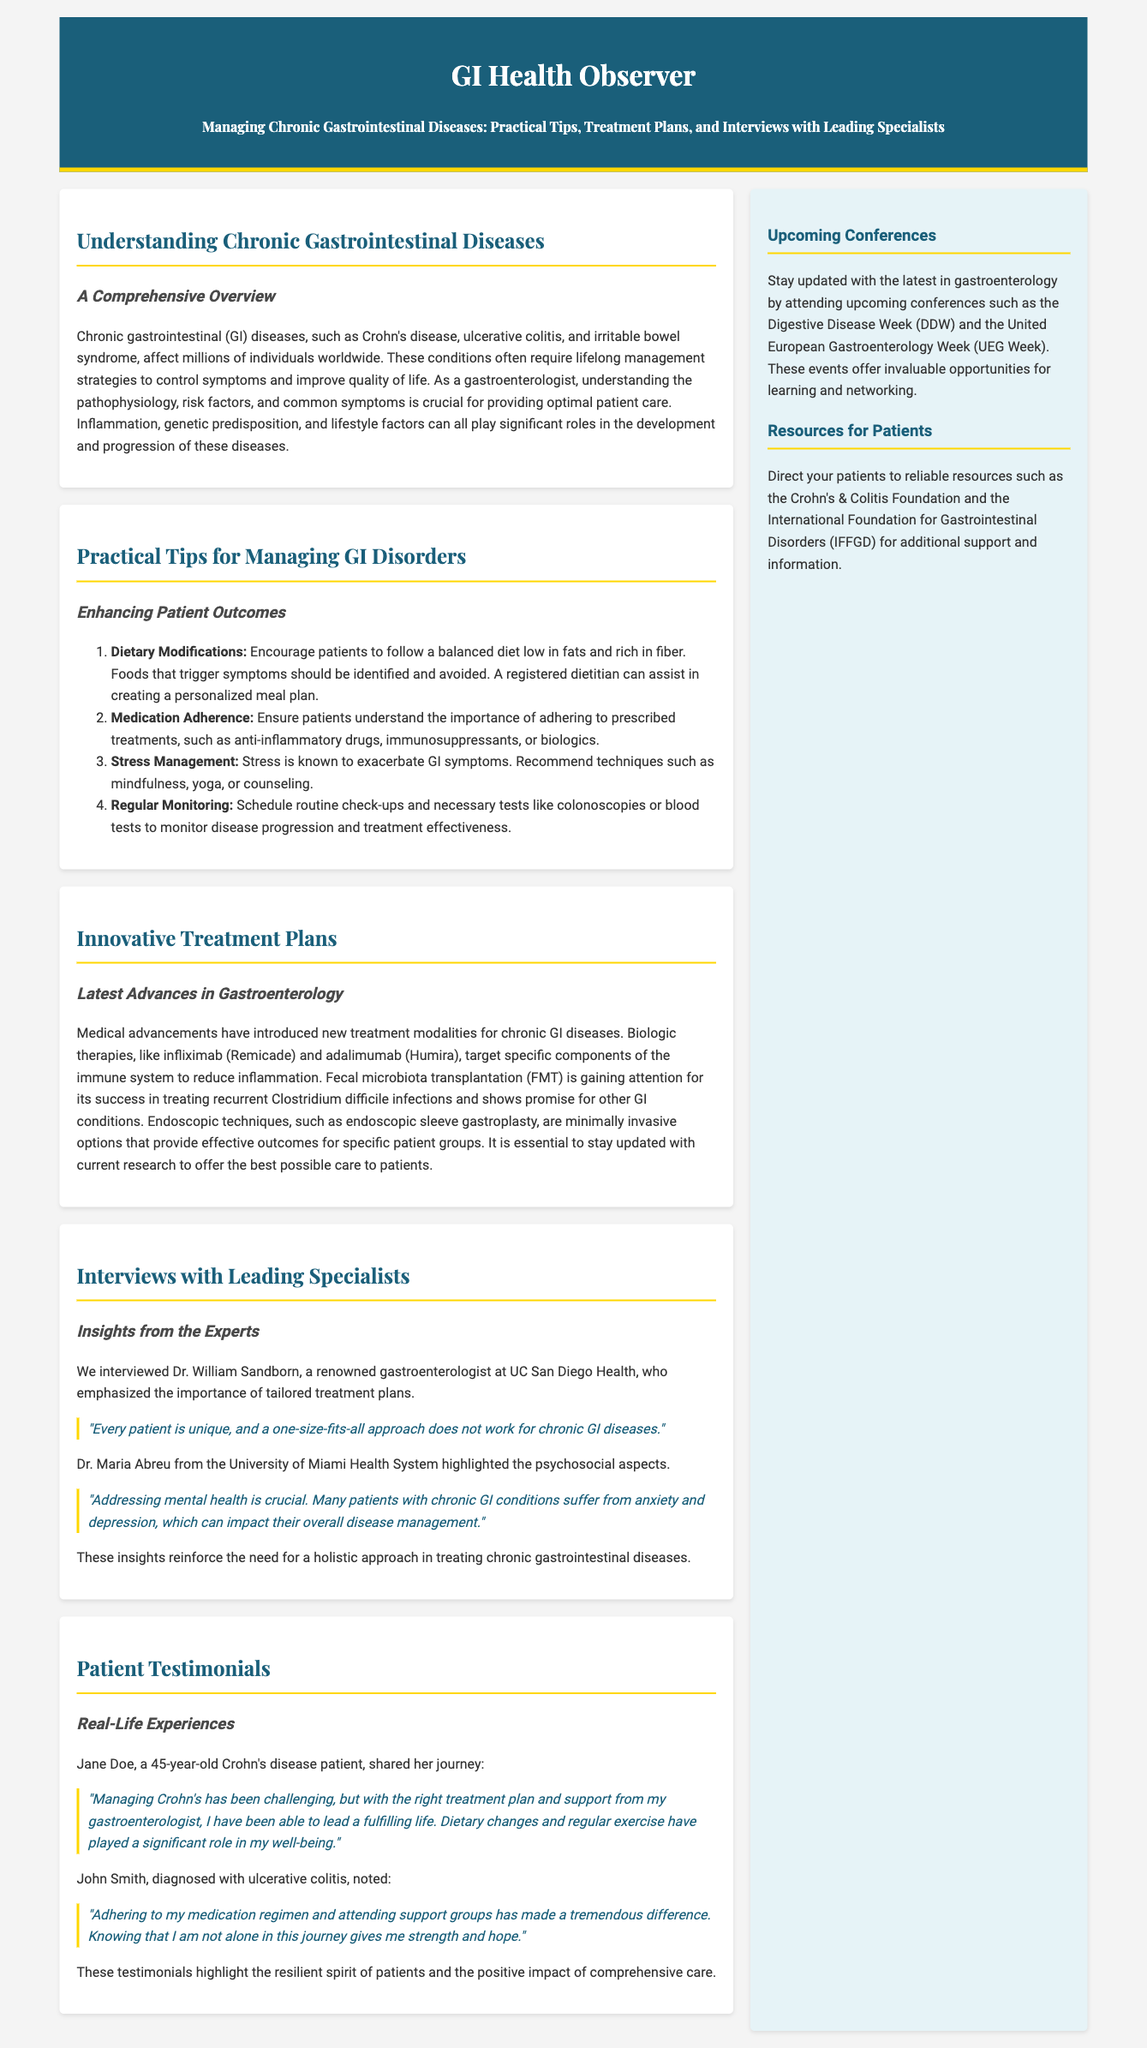What are some examples of chronic gastrointestinal diseases? The document lists several chronic gastrointestinal diseases including Crohn's disease and ulcerative colitis.
Answer: Crohn's disease, ulcerative colitis What is a recommended dietary modification for managing GI disorders? The document suggests that a balanced diet low in fats and rich in fiber is important for managing GI disorders.
Answer: Low in fats and rich in fiber Which therapy targets specific components of the immune system? Biologic therapies such as infliximab and adalimumab are highlighted as treatments that target the immune system.
Answer: Biologic therapies Who emphasized tailored treatment plans in the document? Dr. William Sandborn, a gastroenterologist at UC San Diego Health, is quoted regarding tailored treatment plans.
Answer: Dr. William Sandborn What is a common psychosocial impact mentioned for patients with chronic GI conditions? Anxiety and depression are noted as common psychosocial impacts affecting patients.
Answer: Anxiety and depression Which upcoming conference is mentioned in the document? The Digestive Disease Week (DDW) is listed as an upcoming conference in gastroenterology.
Answer: Digestive Disease Week (DDW) What is a significant aspect of patient care emphasized in the testimonials? The testimonials highlight the importance of support from gastroenterologists and adherence to treatment.
Answer: Support from gastroenterologists What type of document is this? The structure and content indicate that this is a newspaper layout focusing on health.
Answer: Newspaper layout 